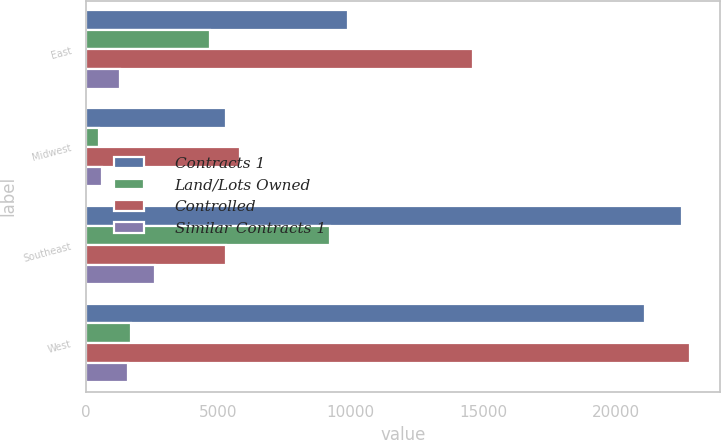Convert chart to OTSL. <chart><loc_0><loc_0><loc_500><loc_500><stacked_bar_chart><ecel><fcel>East<fcel>Midwest<fcel>Southeast<fcel>West<nl><fcel>Contracts 1<fcel>9900<fcel>5300<fcel>22500<fcel>21100<nl><fcel>Land/Lots Owned<fcel>4700<fcel>500<fcel>9200<fcel>1700<nl><fcel>Controlled<fcel>14600<fcel>5800<fcel>5300<fcel>22800<nl><fcel>Similar Contracts 1<fcel>1300<fcel>600<fcel>2600<fcel>1600<nl></chart> 